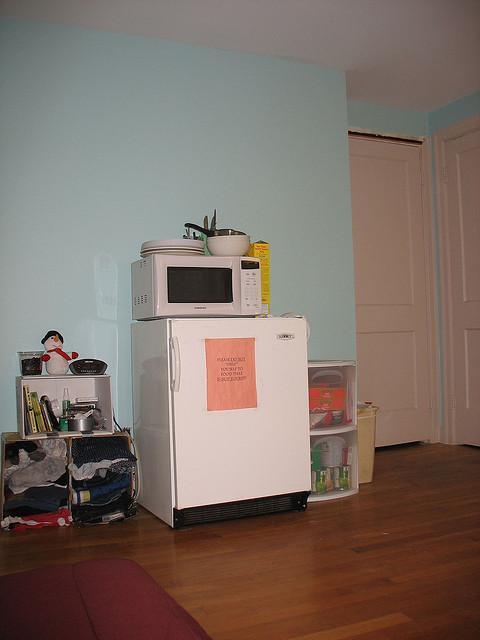How many cars are there with yellow color?
Give a very brief answer. 0. 